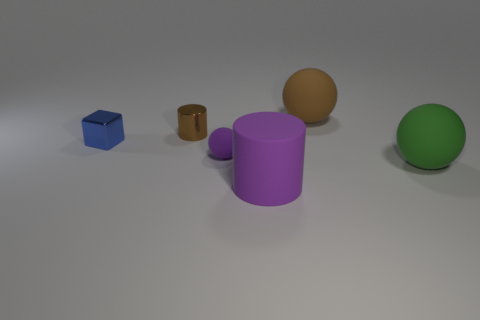Are there any other things that have the same size as the green thing?
Your answer should be very brief. Yes. What is the material of the small object that is the same shape as the big brown matte thing?
Make the answer very short. Rubber. There is a purple matte thing that is behind the rubber ball that is on the right side of the large brown matte ball; is there a small blue block that is in front of it?
Give a very brief answer. No. Do the tiny brown shiny object behind the small block and the purple matte thing behind the big cylinder have the same shape?
Offer a very short reply. No. Is the number of brown matte objects in front of the big green ball greater than the number of large brown rubber spheres?
Offer a terse response. No. How many things are either brown cylinders or large purple objects?
Offer a very short reply. 2. What is the color of the tiny rubber thing?
Your response must be concise. Purple. How many other things are the same color as the tiny sphere?
Make the answer very short. 1. There is a small brown cylinder; are there any brown cylinders left of it?
Your answer should be very brief. No. There is a big rubber ball that is behind the big matte sphere to the right of the big thing that is behind the green object; what color is it?
Your answer should be compact. Brown. 